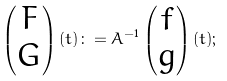Convert formula to latex. <formula><loc_0><loc_0><loc_500><loc_500>\begin{pmatrix} F \\ G \end{pmatrix} ( t ) \colon = A ^ { - 1 } \begin{pmatrix} f \\ g \end{pmatrix} ( t ) ;</formula> 